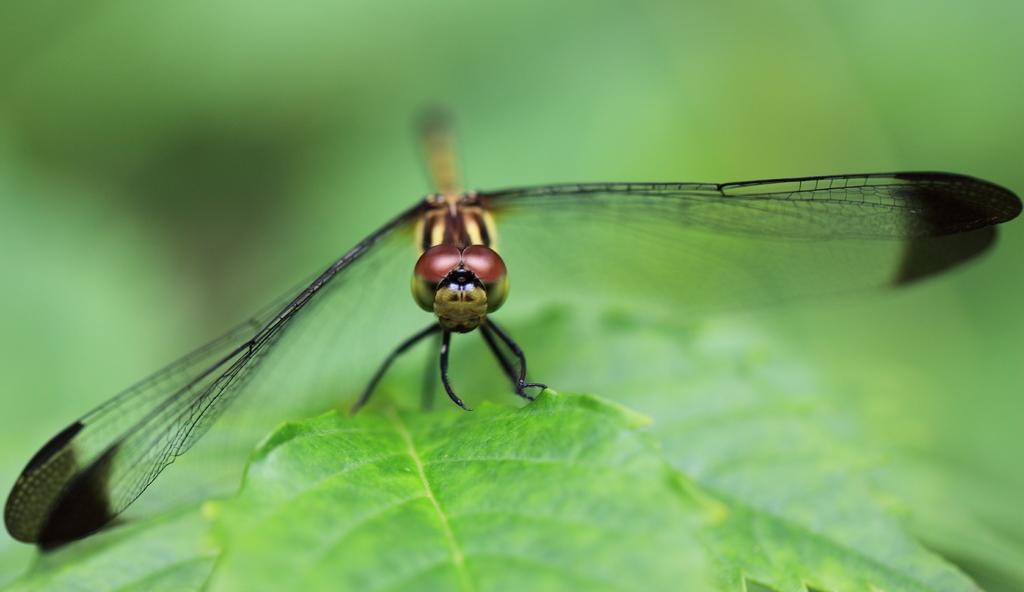What type of creature is in the picture? There is an insect in the picture. What feature does the insect have? The insect has wings. What other object is present in the picture? There is a leaf in the picture. How would you describe the background of the image? The backdrop is blurred. What type of design can be seen on the square jail in the image? There is no square jail present in the image, so it is not possible to answer that question. 